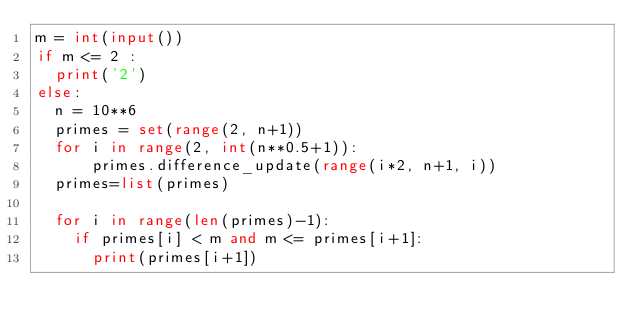Convert code to text. <code><loc_0><loc_0><loc_500><loc_500><_Python_>m = int(input())
if m <= 2 :
  print('2')
else:
  n = 10**6
  primes = set(range(2, n+1))
  for i in range(2, int(n**0.5+1)):
      primes.difference_update(range(i*2, n+1, i))
  primes=list(primes)

  for i in range(len(primes)-1):
    if primes[i] < m and m <= primes[i+1]:
      print(primes[i+1])</code> 